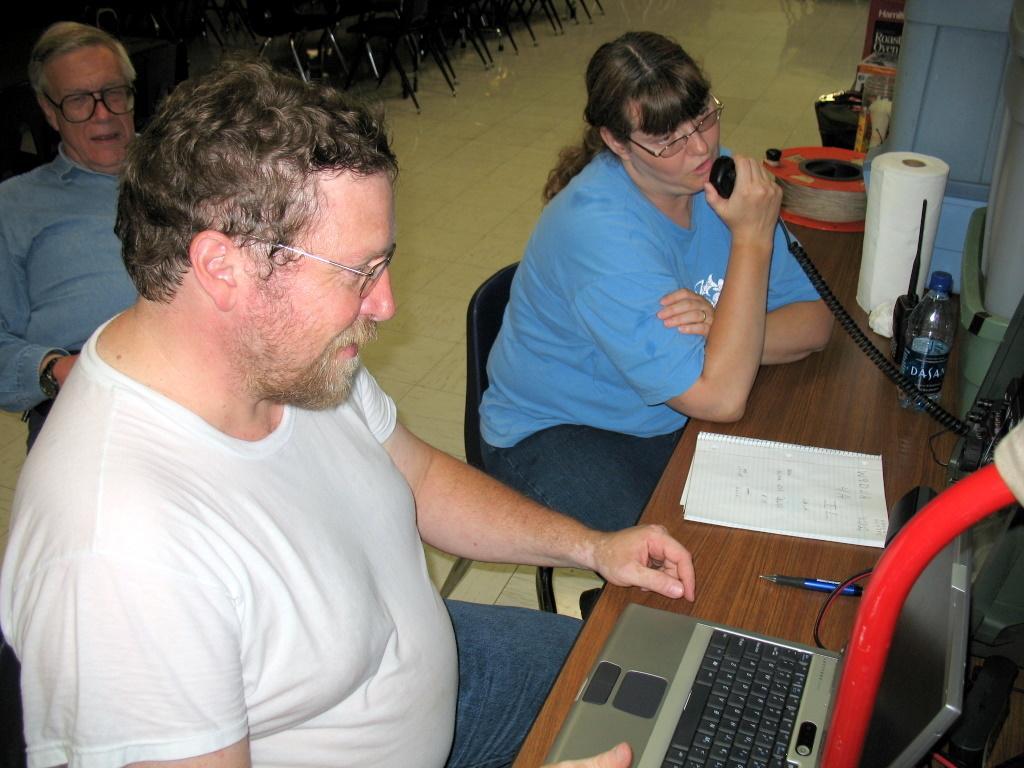How would you summarize this image in a sentence or two? In this image there are three persons sitting on the chair, there are group of chairs truncated towards the top of the image, there are objects on the table, there is a laptop on the table, there are objects truncated towards the right of the image, there are objects on the ground. 